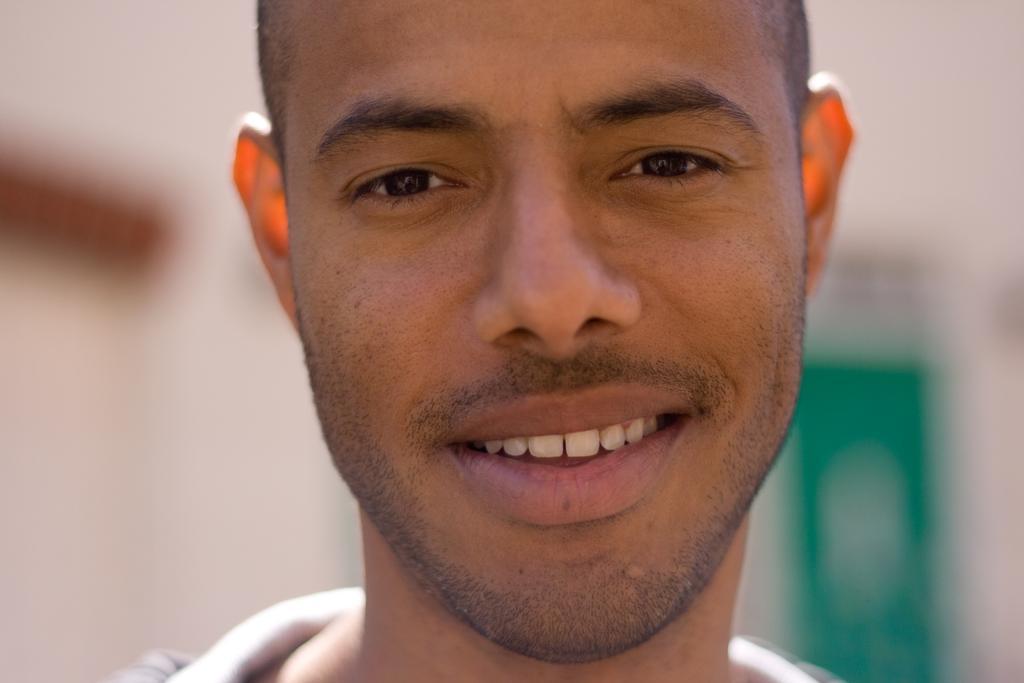Describe this image in one or two sentences. In the picture we can see a man's face with a smile and behind him we can see some things are placed which are not clearly visible. 